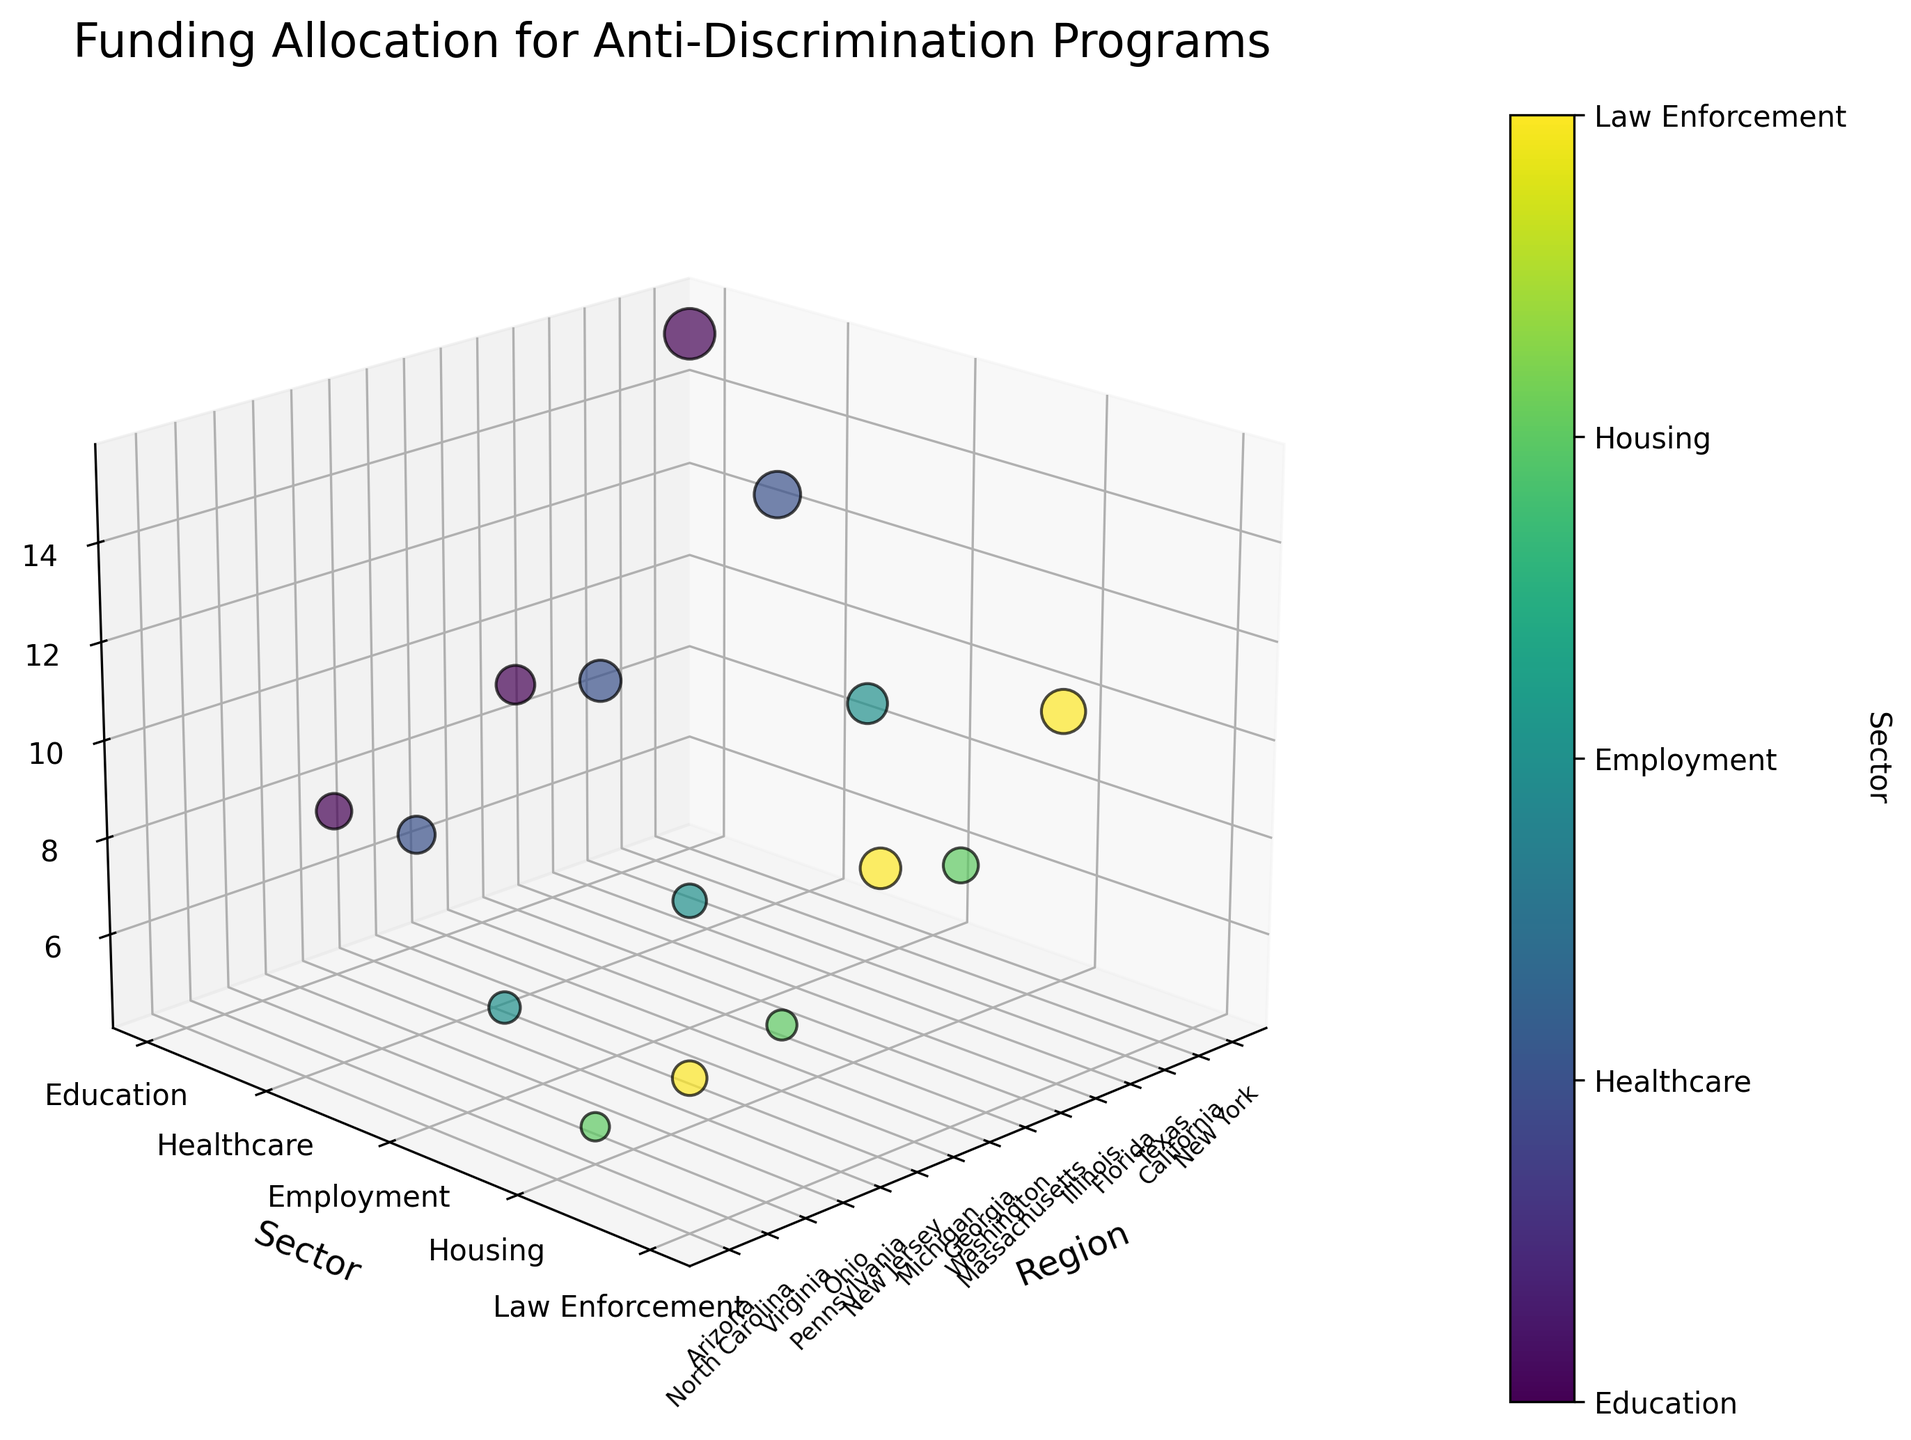Which region allocated the most funding to Education? Look at the 'Region' labels and their corresponding 'Sector' labels. Find the subset where 'Sector' is 'Education' and identify the maximum 'Funding (Millions USD)' value among them.
Answer: New York Which sector received the most funding in California? Identify the data point corresponding to California by checking 'Region'. Note the 'Sector' associated with it and the 'Funding (Millions USD)'.
Answer: Healthcare What's the total funding allocated to the Healthcare sector? Sum the 'Funding (Millions USD)' for all data points where 'Sector' is 'Healthcare'.
Answer: 31.1 Which region has the smallest funding allocation for Housing? Identify all data points where 'Sector' is 'Housing'. Compare their 'Funding (Millions USD)' values to find the minimum.
Answer: North Carolina Compare the funding allocation for Law Enforcement between Illinois and New Jersey. Which one is higher? Identify the data points for Illinois and New Jersey with 'Sector' as 'Law Enforcement'. Compare their 'Funding (Millions USD)' values to determine which is higher.
Answer: Illinois How much more funding did New York allocate to Education compared to Pennsylvania? Identify the 'Funding (Millions USD)' values for New York and Pennsylvania where 'Sector' is 'Education'. Calculate the difference between the two values.
Answer: 7.7 Which sector received the highest funding in Texas, and how much was it? Locate Texas in the 'Region' labels. Identify the 'Sector' and note its 'Funding (Millions USD)'.
Answer: Employment, 9.5 What's the average funding allocated per region? Count the total number of regions. Sum all 'Funding (Millions USD)' values and divide by the number of regions.
Answer: 8.42 Calculate the difference in funding for Employment between Texas and Georgia. Identify the 'Funding (Millions USD)' values for Texas and Georgia where 'Sector' is 'Employment'. Compute the absolute difference between them.
Answer: 2.8 Which sector has the highest variability in funding allocation across regions? For each sector, calculate the variance of 'Funding (Millions USD)' across all regions. Identify the sector with the highest variance.
Answer: Education 